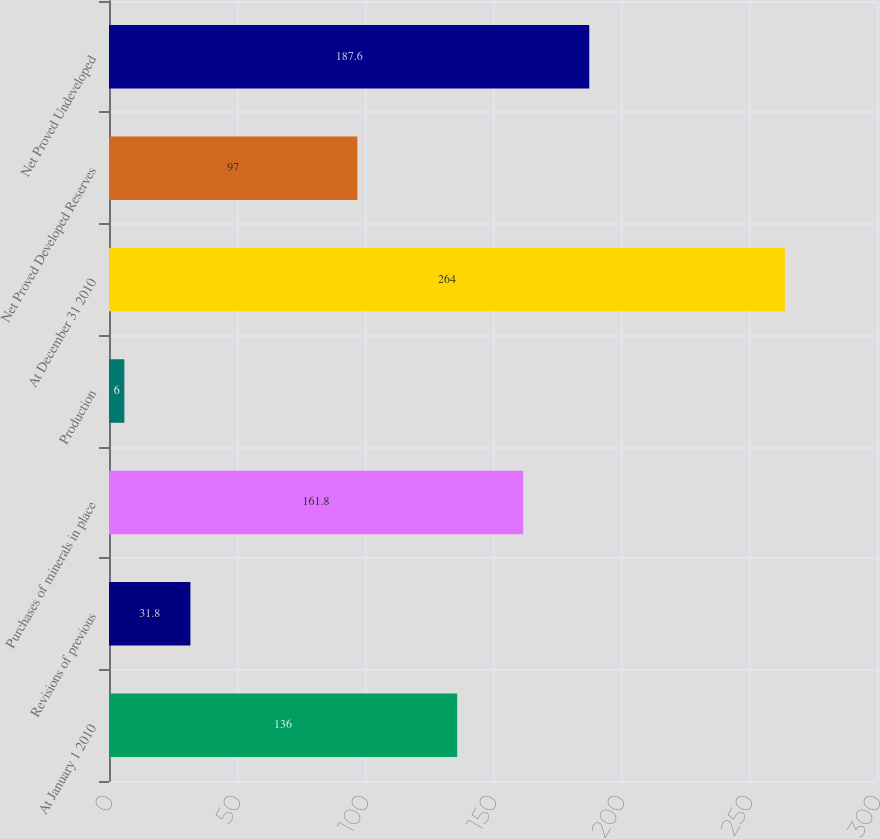<chart> <loc_0><loc_0><loc_500><loc_500><bar_chart><fcel>At January 1 2010<fcel>Revisions of previous<fcel>Purchases of minerals in place<fcel>Production<fcel>At December 31 2010<fcel>Net Proved Developed Reserves<fcel>Net Proved Undeveloped<nl><fcel>136<fcel>31.8<fcel>161.8<fcel>6<fcel>264<fcel>97<fcel>187.6<nl></chart> 